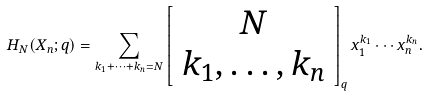Convert formula to latex. <formula><loc_0><loc_0><loc_500><loc_500>H _ { N } ( X _ { n } ; q ) = \sum _ { k _ { 1 } + \cdots + k _ { n } = N } \left [ \begin{array} { c } N \\ k _ { 1 } , \dots , k _ { n } \end{array} \right ] _ { q } x _ { 1 } ^ { k _ { 1 } } \cdots x _ { n } ^ { k _ { n } } .</formula> 